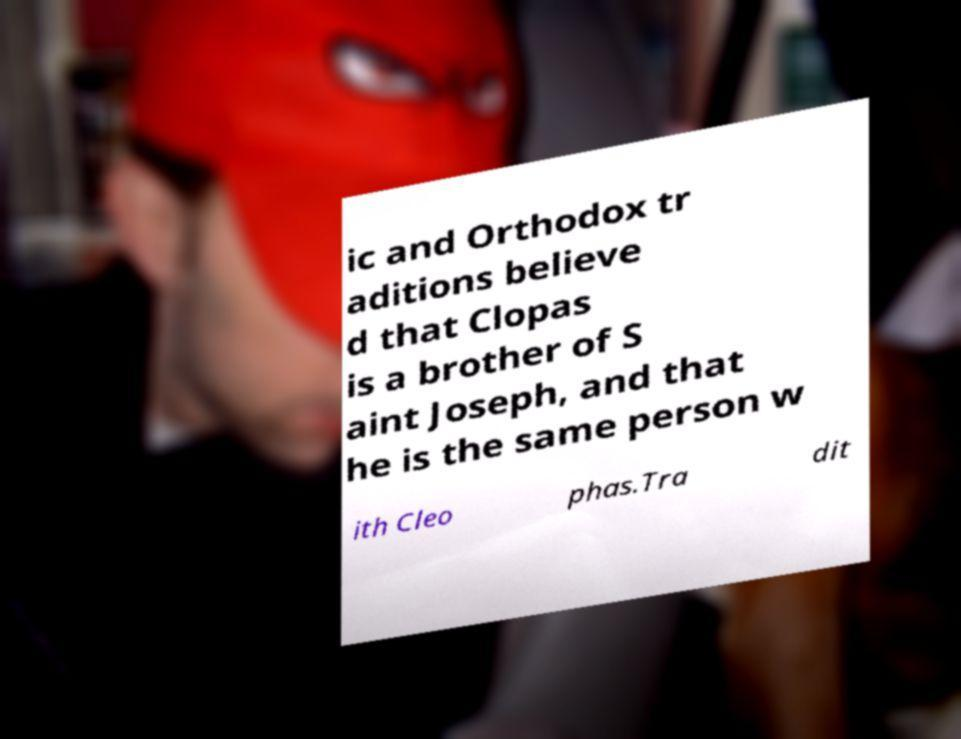I need the written content from this picture converted into text. Can you do that? ic and Orthodox tr aditions believe d that Clopas is a brother of S aint Joseph, and that he is the same person w ith Cleo phas.Tra dit 